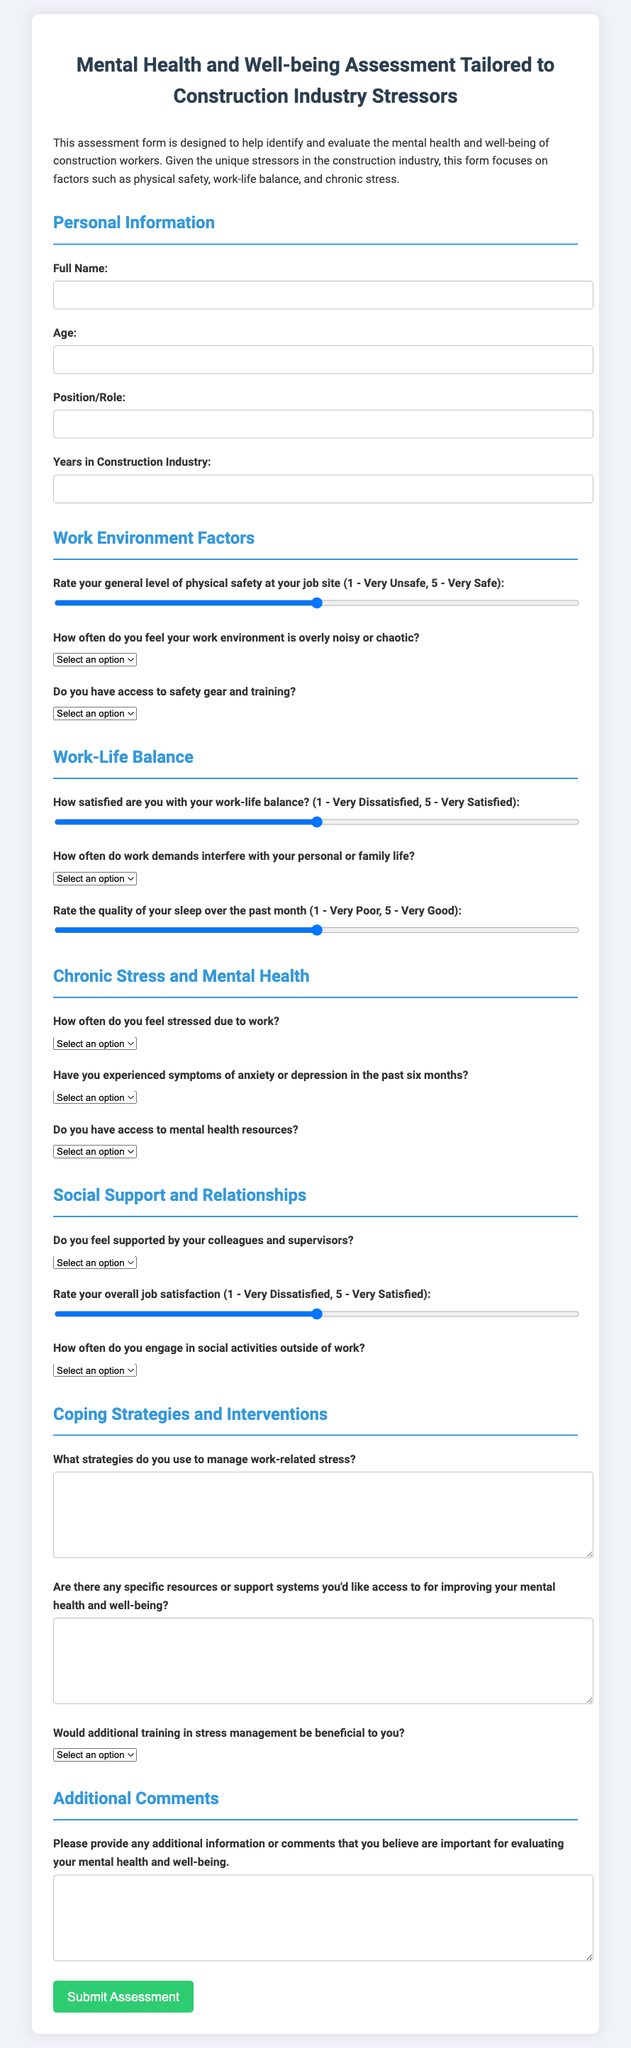what is the title of the document? The title is provided in the document's heading, summarizing the purpose of the assessment form.
Answer: Mental Health and Well-being Assessment Tailored to Construction Industry Stressors how many sections are in the form? The form is divided into multiple sections focusing on different aspects of mental health and well-being.
Answer: Six what is the minimum age input for the assessment? The document specifies the age input type used in the personal information section, which indicates the minimum value accepted.
Answer: 1 what rating scale is used to assess work-life balance? The form utilizes a rating scale for work-life balance in a specific range that is defined in the section.
Answer: 1 - Very Dissatisfied, 5 - Very Satisfied do you have access to safety gear and training? This question is provided in the work environment factors section, indicating the availability of essential resources.
Answer: Yes / No how frequently should stress be indicated in the stress frequency question? The document provides options in the stress frequency section, allowing for self-assessment of stress levels.
Answer: Never / Rarely / Sometimes / Often / Always what is asked about coping strategies? The form includes a question to understand how individuals manage stress, requiring a descriptive response from the participant.
Answer: What strategies do you use to manage work-related stress? what type of training is mentioned as potentially beneficial? The document specifically asks participants about the relevance of a certain training type relating to their stress management skills.
Answer: Stress management training how would you rate the quality of sleep? The quality of sleep is evaluated on a defined scale in the chronic stress and mental health section of the form.
Answer: 1 - Very Poor, 5 - Very Good 